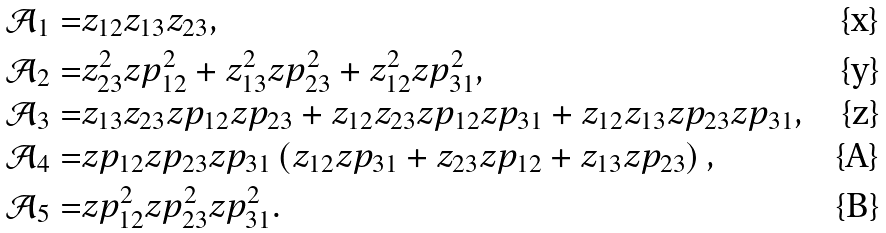Convert formula to latex. <formula><loc_0><loc_0><loc_500><loc_500>\mathcal { A } _ { 1 } = & z _ { 1 2 } z _ { 1 3 } z _ { 2 3 } , \\ \mathcal { A } _ { 2 } = & z _ { 2 3 } ^ { 2 } z p _ { 1 2 } ^ { 2 } + z _ { 1 3 } ^ { 2 } z p _ { 2 3 } ^ { 2 } + z _ { 1 2 } ^ { 2 } z p _ { 3 1 } ^ { 2 } , \\ \mathcal { A } _ { 3 } = & z _ { 1 3 } z _ { 2 3 } z p _ { 1 2 } z p _ { 2 3 } + z _ { 1 2 } z _ { 2 3 } z p _ { 1 2 } z p _ { 3 1 } + z _ { 1 2 } z _ { 1 3 } z p _ { 2 3 } z p _ { 3 1 } , \\ \mathcal { A } _ { 4 } = & z p _ { 1 2 } z p _ { 2 3 } z p _ { 3 1 } \left ( z _ { 1 2 } z p _ { 3 1 } + z _ { 2 3 } z p _ { 1 2 } + z _ { 1 3 } z p _ { 2 3 } \right ) , \\ \mathcal { A } _ { 5 } = & z p _ { 1 2 } ^ { 2 } z p _ { 2 3 } ^ { 2 } z p _ { 3 1 } ^ { 2 } .</formula> 